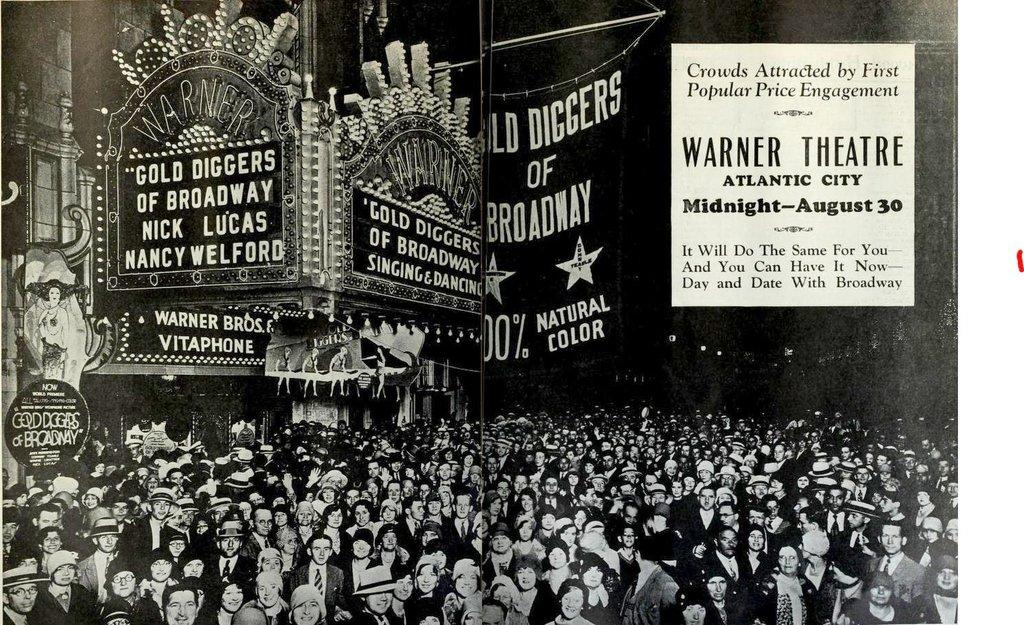Provide a one-sentence caption for the provided image. An old time photograph shows a vintage New York theater presenting "Gold Diggers of Broadway". 